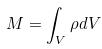Convert formula to latex. <formula><loc_0><loc_0><loc_500><loc_500>M = \int _ { V } \rho d V</formula> 